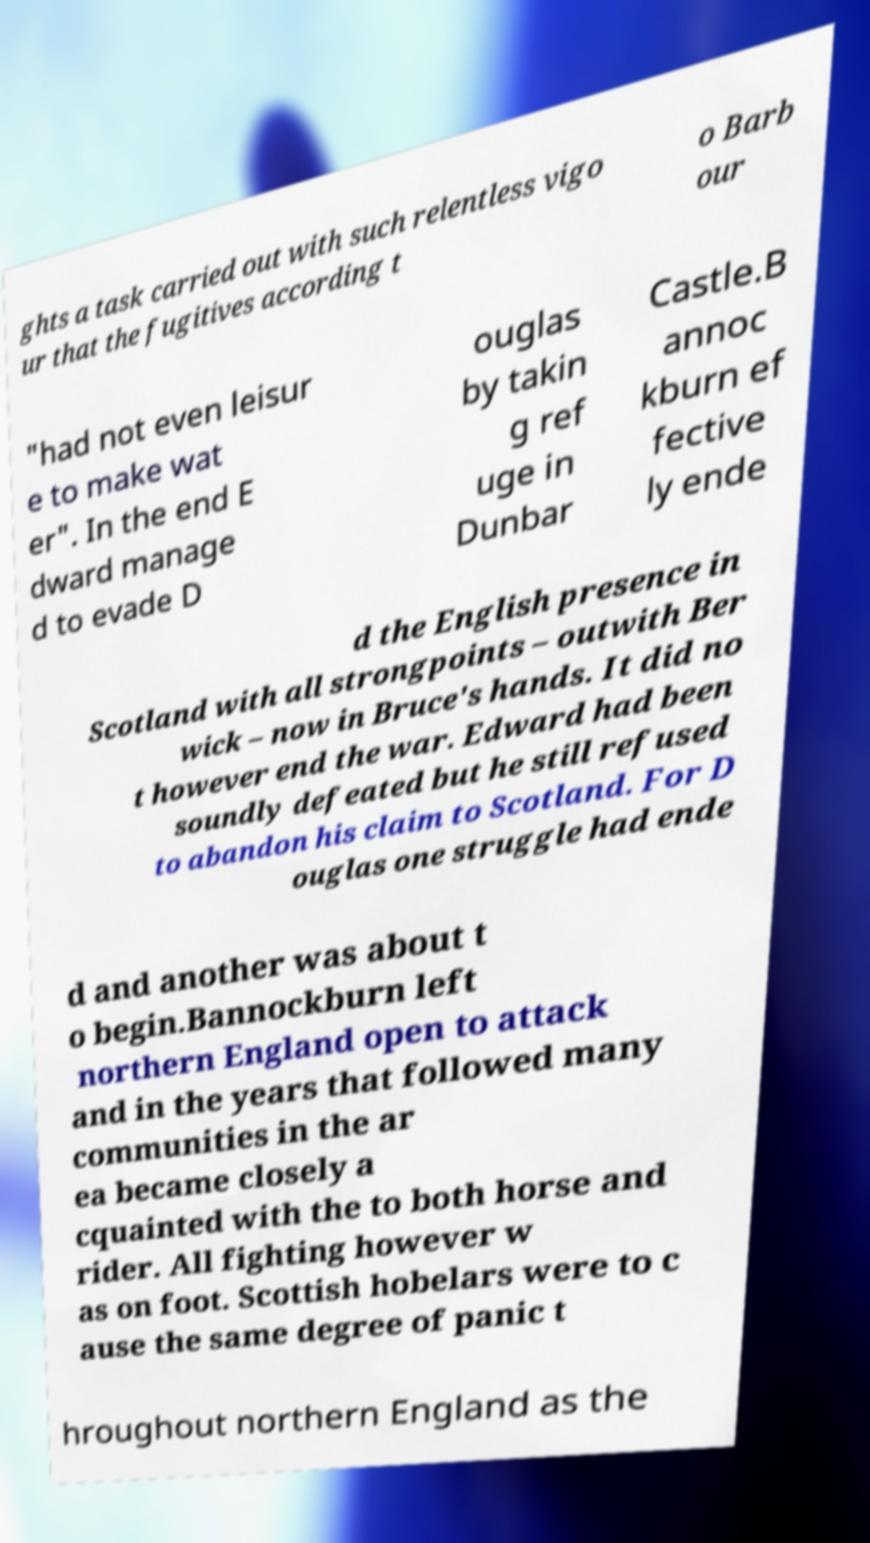There's text embedded in this image that I need extracted. Can you transcribe it verbatim? ghts a task carried out with such relentless vigo ur that the fugitives according t o Barb our "had not even leisur e to make wat er". In the end E dward manage d to evade D ouglas by takin g ref uge in Dunbar Castle.B annoc kburn ef fective ly ende d the English presence in Scotland with all strongpoints – outwith Ber wick – now in Bruce's hands. It did no t however end the war. Edward had been soundly defeated but he still refused to abandon his claim to Scotland. For D ouglas one struggle had ende d and another was about t o begin.Bannockburn left northern England open to attack and in the years that followed many communities in the ar ea became closely a cquainted with the to both horse and rider. All fighting however w as on foot. Scottish hobelars were to c ause the same degree of panic t hroughout northern England as the 